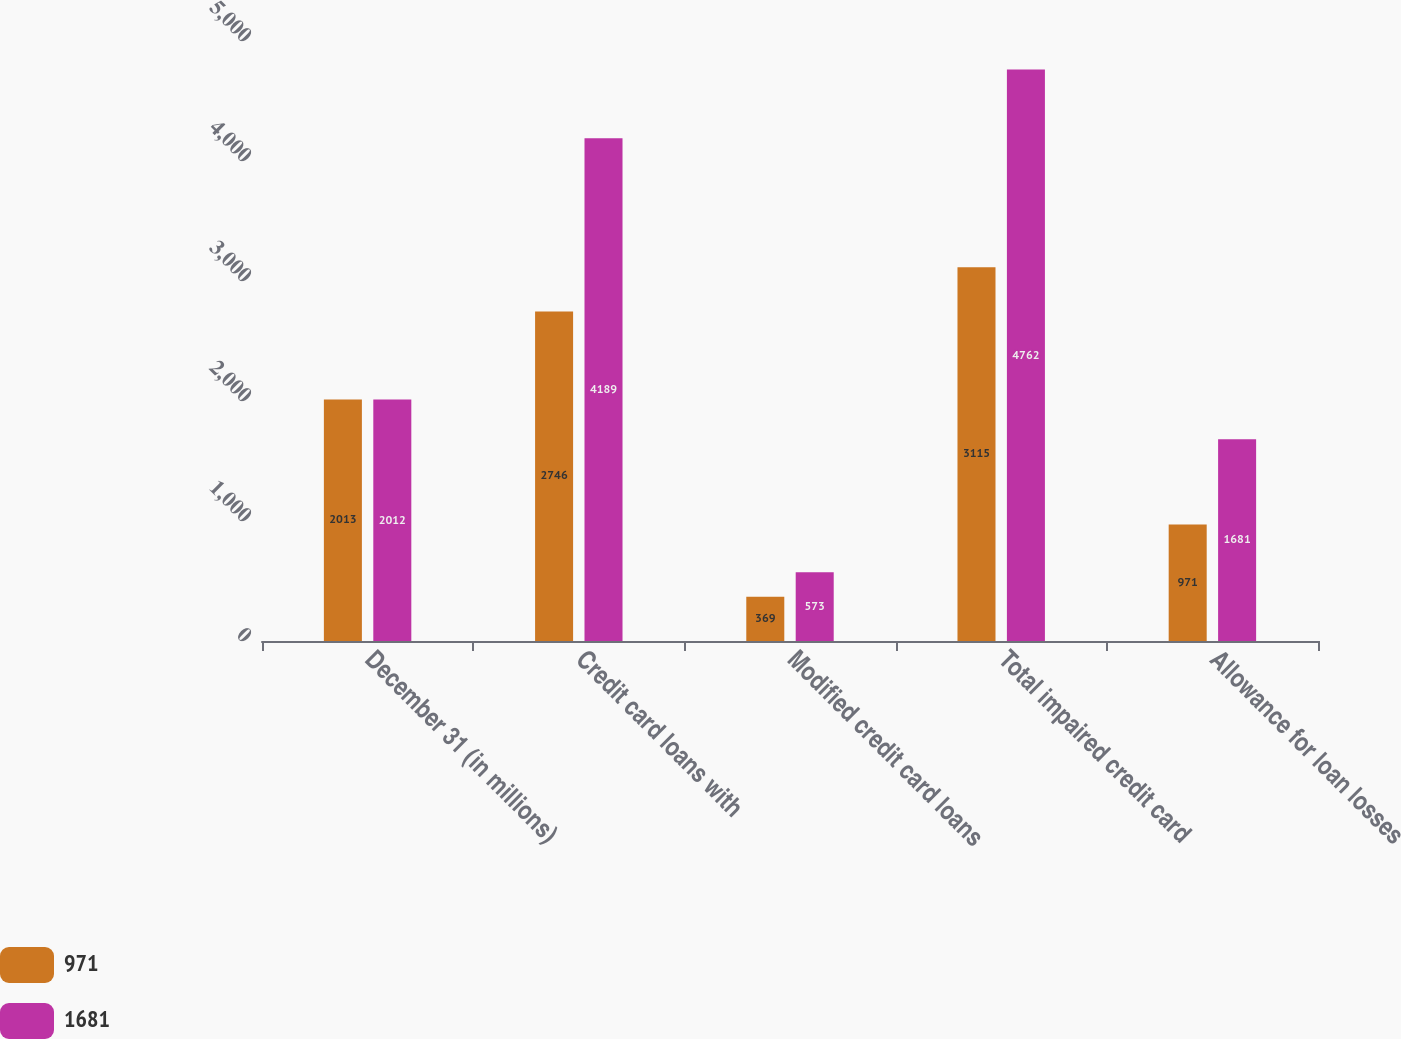Convert chart. <chart><loc_0><loc_0><loc_500><loc_500><stacked_bar_chart><ecel><fcel>December 31 (in millions)<fcel>Credit card loans with<fcel>Modified credit card loans<fcel>Total impaired credit card<fcel>Allowance for loan losses<nl><fcel>971<fcel>2013<fcel>2746<fcel>369<fcel>3115<fcel>971<nl><fcel>1681<fcel>2012<fcel>4189<fcel>573<fcel>4762<fcel>1681<nl></chart> 